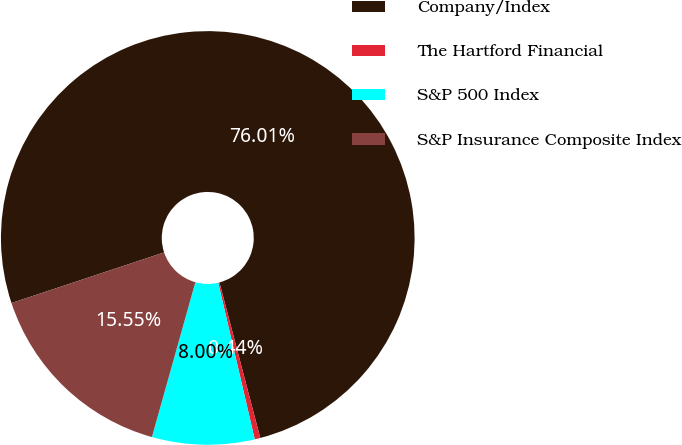Convert chart to OTSL. <chart><loc_0><loc_0><loc_500><loc_500><pie_chart><fcel>Company/Index<fcel>The Hartford Financial<fcel>S&P 500 Index<fcel>S&P Insurance Composite Index<nl><fcel>76.0%<fcel>0.44%<fcel>8.0%<fcel>15.55%<nl></chart> 